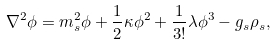Convert formula to latex. <formula><loc_0><loc_0><loc_500><loc_500>\nabla ^ { 2 } \phi = m _ { s } ^ { 2 } \phi + \frac { 1 } { 2 } \kappa \phi ^ { 2 } + \frac { 1 } { 3 ! } \lambda \phi ^ { 3 } - g _ { s } \rho _ { s } ,</formula> 